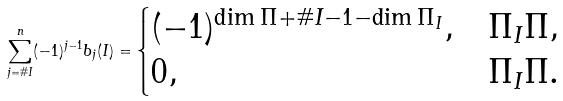<formula> <loc_0><loc_0><loc_500><loc_500>\sum _ { j = \# I } ^ { n } ( - 1 ) ^ { j - 1 } b _ { j } ( I ) = \begin{cases} ( - 1 ) ^ { \dim \Pi + \# I - 1 - \dim \Pi _ { I } } , & \Pi _ { I } \Pi , \\ 0 , & \Pi _ { I } \Pi . \end{cases}</formula> 